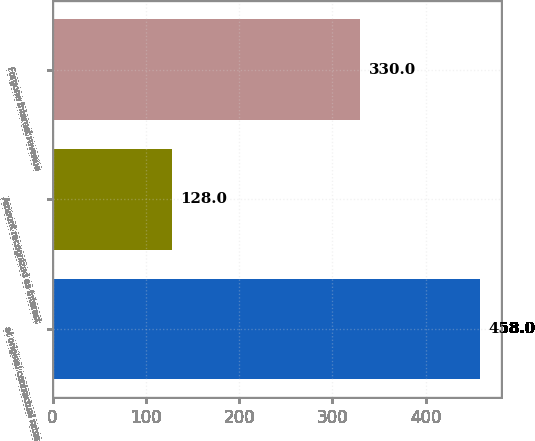Convert chart. <chart><loc_0><loc_0><loc_500><loc_500><bar_chart><fcel>at original contractual rates<fcel>Amount recognized as interest<fcel>Forgone interest revenue<nl><fcel>458<fcel>128<fcel>330<nl></chart> 